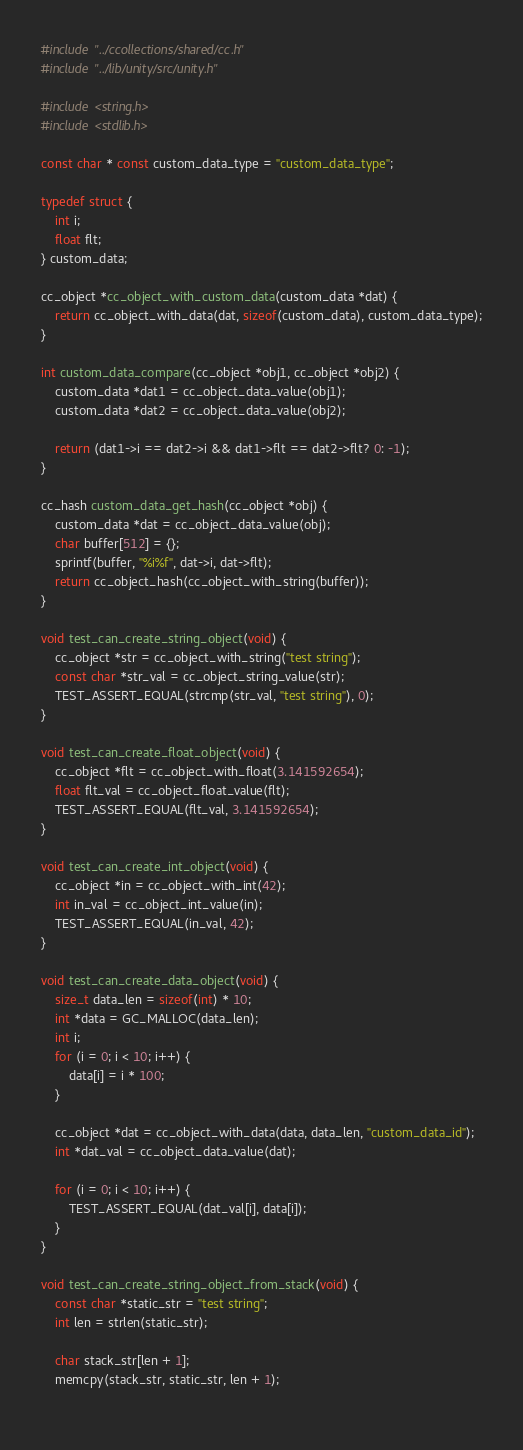Convert code to text. <code><loc_0><loc_0><loc_500><loc_500><_C_>#include "../ccollections/shared/cc.h"
#include "../lib/unity/src/unity.h"

#include <string.h>
#include <stdlib.h>

const char * const custom_data_type = "custom_data_type";

typedef struct {
	int i;
	float flt;
} custom_data;

cc_object *cc_object_with_custom_data(custom_data *dat) {
	return cc_object_with_data(dat, sizeof(custom_data), custom_data_type);
}

int custom_data_compare(cc_object *obj1, cc_object *obj2) {
	custom_data *dat1 = cc_object_data_value(obj1);
	custom_data *dat2 = cc_object_data_value(obj2);
	
	return (dat1->i == dat2->i && dat1->flt == dat2->flt? 0: -1);
}

cc_hash custom_data_get_hash(cc_object *obj) {
	custom_data *dat = cc_object_data_value(obj);
	char buffer[512] = {};
	sprintf(buffer, "%i%f", dat->i, dat->flt);
	return cc_object_hash(cc_object_with_string(buffer));
}

void test_can_create_string_object(void) {
	cc_object *str = cc_object_with_string("test string");
	const char *str_val = cc_object_string_value(str);
	TEST_ASSERT_EQUAL(strcmp(str_val, "test string"), 0);
}

void test_can_create_float_object(void) {
	cc_object *flt = cc_object_with_float(3.141592654);
	float flt_val = cc_object_float_value(flt);
	TEST_ASSERT_EQUAL(flt_val, 3.141592654);
}

void test_can_create_int_object(void) {
	cc_object *in = cc_object_with_int(42);
	int in_val = cc_object_int_value(in);
	TEST_ASSERT_EQUAL(in_val, 42);
}

void test_can_create_data_object(void) {
	size_t data_len = sizeof(int) * 10;
	int *data = GC_MALLOC(data_len);
	int i;
	for (i = 0; i < 10; i++) {
		data[i] = i * 100;
	}
	
	cc_object *dat = cc_object_with_data(data, data_len, "custom_data_id");
	int *dat_val = cc_object_data_value(dat);
	
	for (i = 0; i < 10; i++) {
		TEST_ASSERT_EQUAL(dat_val[i], data[i]);
	}
}

void test_can_create_string_object_from_stack(void) {
	const char *static_str = "test string";
	int len = strlen(static_str);
	
	char stack_str[len + 1];
	memcpy(stack_str, static_str, len + 1);
	</code> 